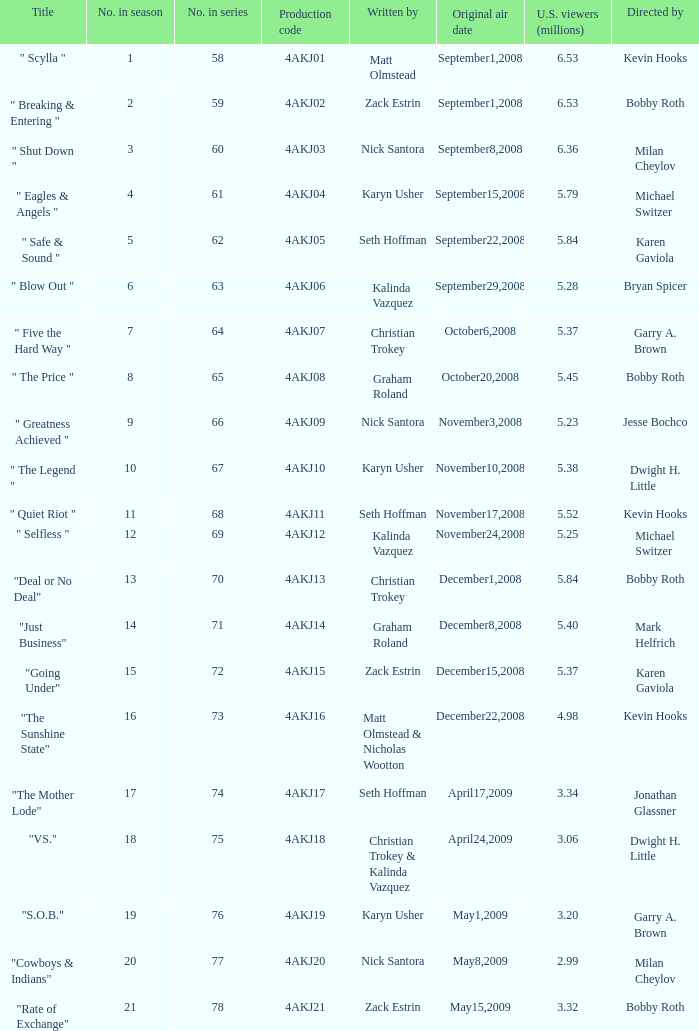Who directed the episode with production code 4akj01? Kevin Hooks. 